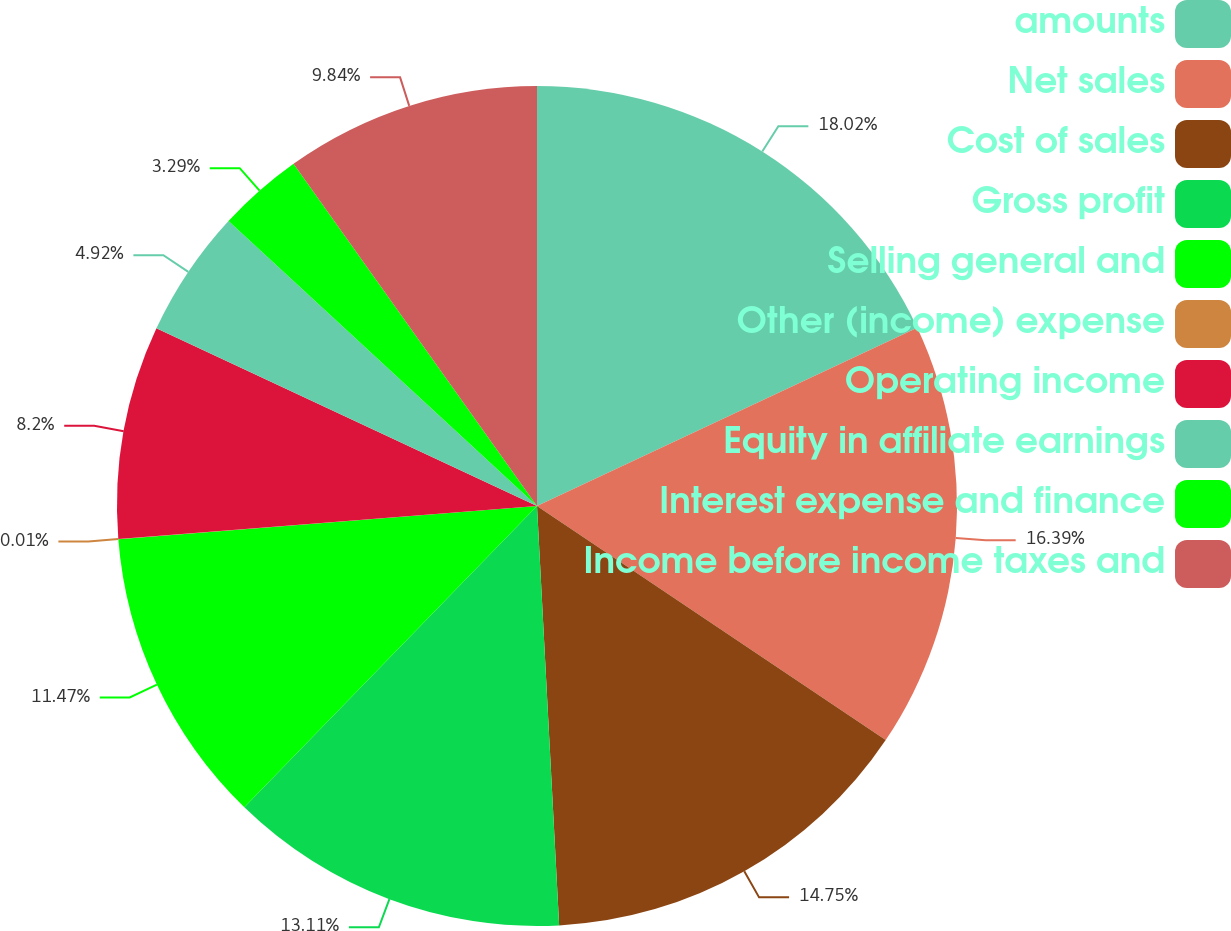Convert chart. <chart><loc_0><loc_0><loc_500><loc_500><pie_chart><fcel>amounts<fcel>Net sales<fcel>Cost of sales<fcel>Gross profit<fcel>Selling general and<fcel>Other (income) expense<fcel>Operating income<fcel>Equity in affiliate earnings<fcel>Interest expense and finance<fcel>Income before income taxes and<nl><fcel>18.02%<fcel>16.39%<fcel>14.75%<fcel>13.11%<fcel>11.47%<fcel>0.01%<fcel>8.2%<fcel>4.92%<fcel>3.29%<fcel>9.84%<nl></chart> 